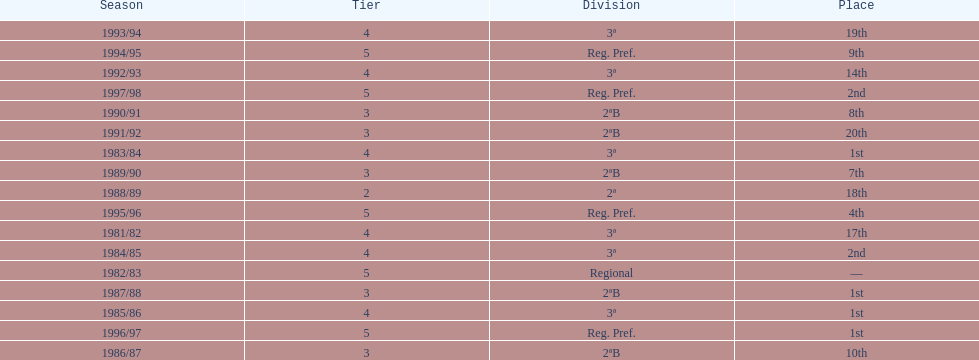How many times total did they finish first 4. 